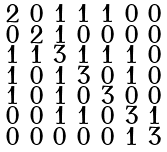Convert formula to latex. <formula><loc_0><loc_0><loc_500><loc_500>\begin{smallmatrix} 2 & 0 & 1 & 1 & 1 & 0 & 0 \\ 0 & 2 & 1 & 0 & 0 & 0 & 0 \\ 1 & 1 & 3 & 1 & 1 & 1 & 0 \\ 1 & 0 & 1 & 3 & 0 & 1 & 0 \\ 1 & 0 & 1 & 0 & 3 & 0 & 0 \\ 0 & 0 & 1 & 1 & 0 & 3 & 1 \\ 0 & 0 & 0 & 0 & 0 & 1 & 3 \end{smallmatrix}</formula> 